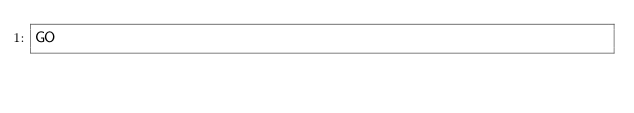<code> <loc_0><loc_0><loc_500><loc_500><_SQL_>GO</code> 